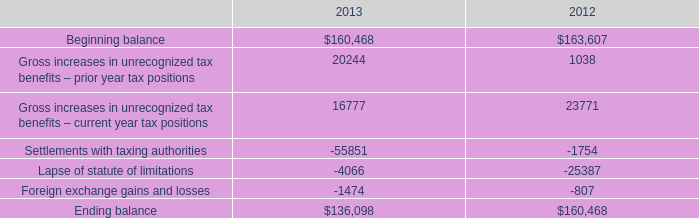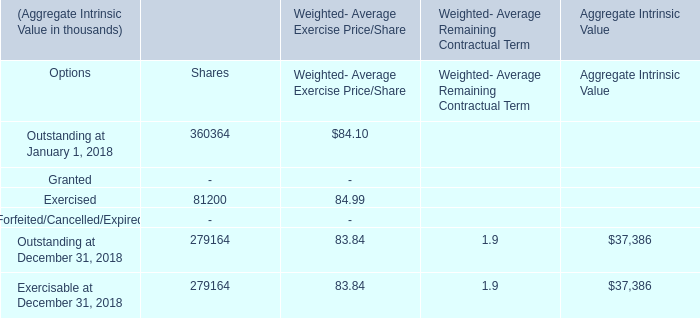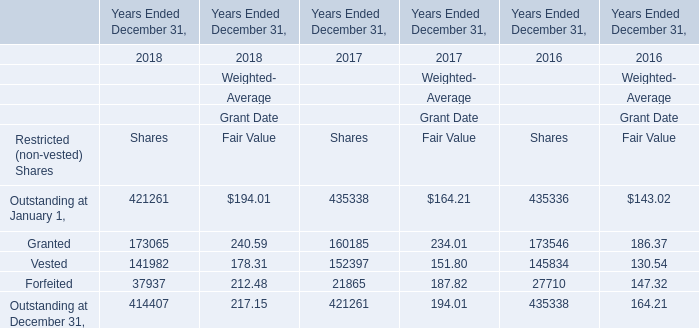What is the average amount of Forfeited of Years Ended December 31, 2016 Shares, and Outstanding at December 31, 2018 of Aggregate Intrinsic Value ? 
Computations: ((27710.0 + 37386.0) / 2)
Answer: 32548.0. 